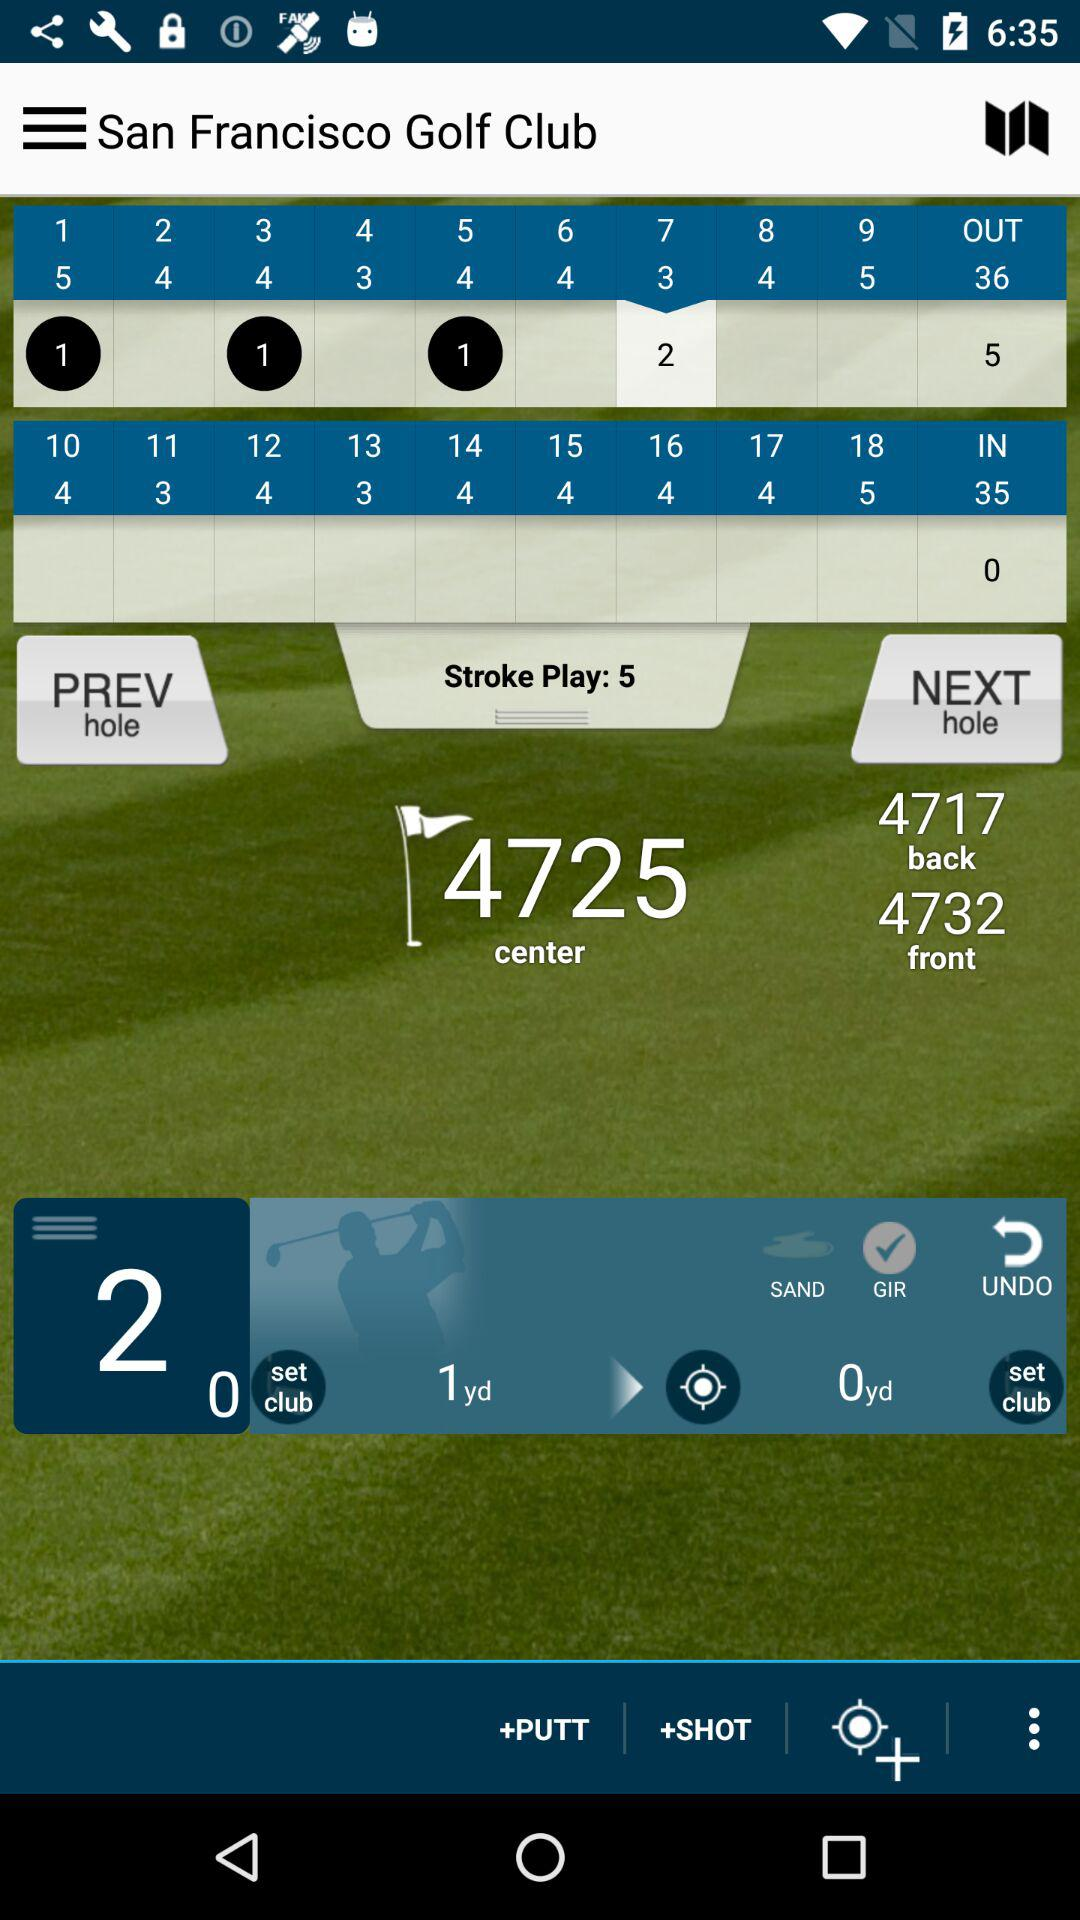What is the total number of "IN"? The total number of "IN" is 35. 